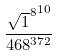Convert formula to latex. <formula><loc_0><loc_0><loc_500><loc_500>\frac { { \sqrt { 1 } ^ { 8 } } ^ { 1 0 } } { 4 6 8 ^ { 3 7 2 } }</formula> 